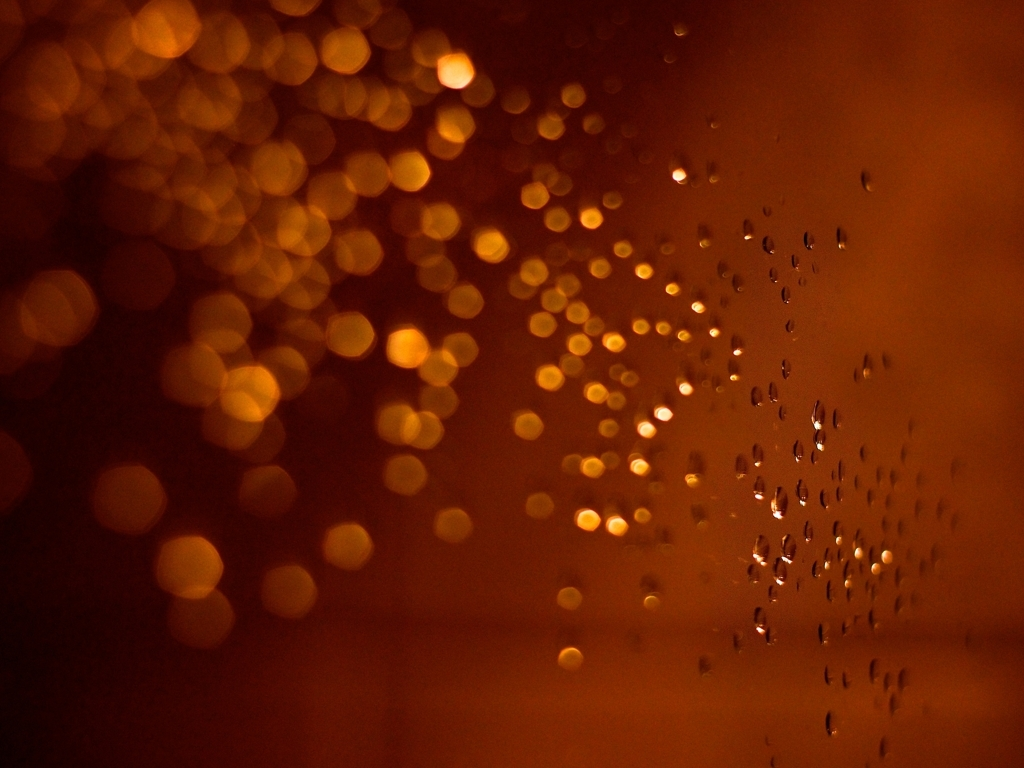Could these water droplets tell us something about the weather outside? Certainly, the presence of water droplets usually indicates recent rain or high humidity outside. The varying sizes of the droplets might also suggest that a gentle rain has just passed, leaving behind these tiny, glistening beads as evidence of the weather's transient nature. What does the bokeh effect reveal about the camera's focus and what might have been the photographer's intention? The bokeh effect shows that the camera's focus was set on the water droplets in the foreground, intentionally blurring the lights in the background to create a sense of depth and artistic allure. The photographer's intention might have been to capture the contrast between the sharpness of the droplets and the diffused glow of the lights, crafting an image that draws the viewer’s eye to the intricate patterns and reflections in each droplet. 